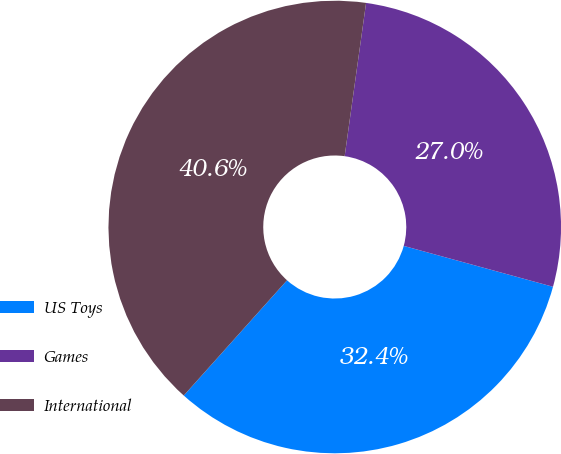<chart> <loc_0><loc_0><loc_500><loc_500><pie_chart><fcel>US Toys<fcel>Games<fcel>International<nl><fcel>32.37%<fcel>27.04%<fcel>40.58%<nl></chart> 